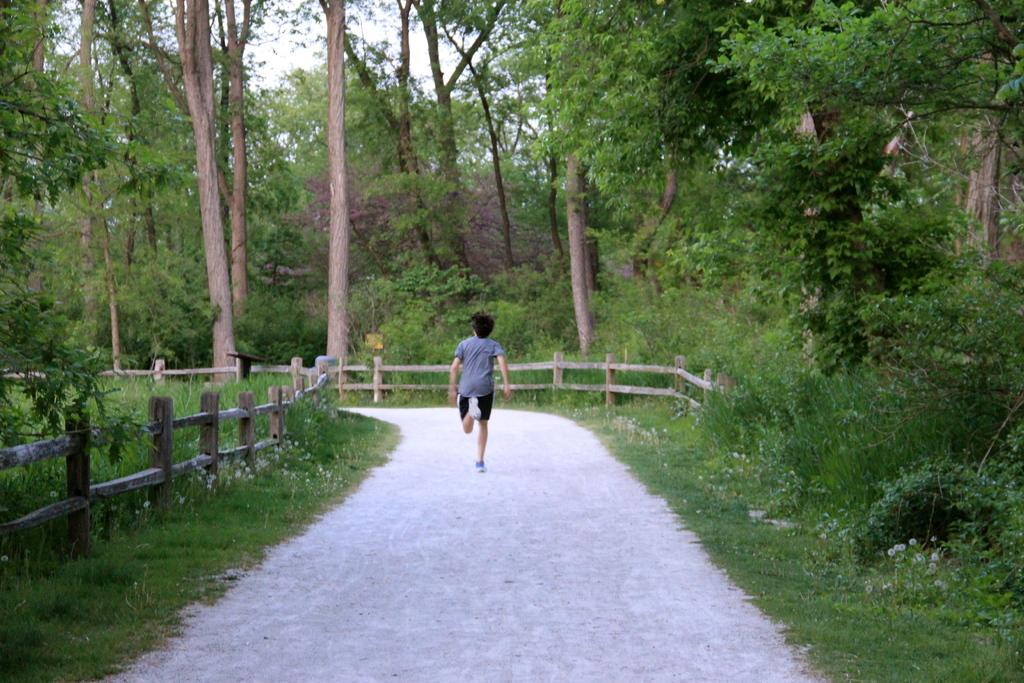What is the person in the image doing? The person is running in the image. Where is the person running? The person is running on a pathway. What type of vegetation can be seen in the image? There are trees, plants, and grass in the image. What type of fencing is present in the image? There are wooden fences in the image. What is visible in the background of the image? The sky is visible in the background of the image. What type of mint is growing in the wilderness in the image? There is no mint or wilderness present in the image. How many accounts does the person have in the image? There is no mention of any accounts in the image. 